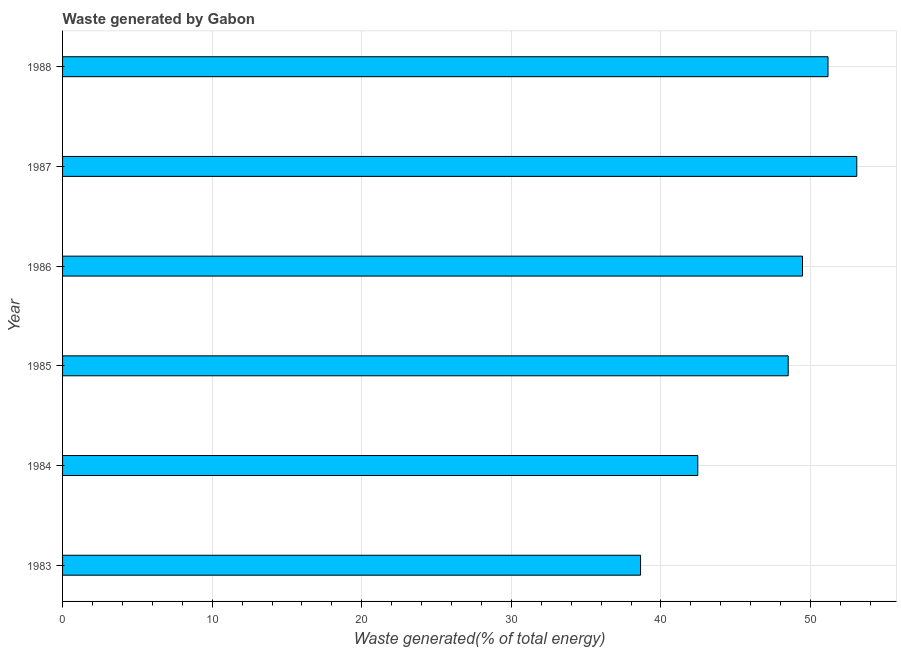Does the graph contain grids?
Your answer should be compact. Yes. What is the title of the graph?
Ensure brevity in your answer.  Waste generated by Gabon. What is the label or title of the X-axis?
Offer a terse response. Waste generated(% of total energy). What is the amount of waste generated in 1984?
Offer a terse response. 42.46. Across all years, what is the maximum amount of waste generated?
Give a very brief answer. 53.09. Across all years, what is the minimum amount of waste generated?
Make the answer very short. 38.64. In which year was the amount of waste generated maximum?
Your response must be concise. 1987. What is the sum of the amount of waste generated?
Provide a short and direct response. 283.33. What is the difference between the amount of waste generated in 1985 and 1986?
Make the answer very short. -0.95. What is the average amount of waste generated per year?
Provide a short and direct response. 47.22. What is the median amount of waste generated?
Keep it short and to the point. 48.99. In how many years, is the amount of waste generated greater than 34 %?
Your answer should be compact. 6. What is the ratio of the amount of waste generated in 1983 to that in 1986?
Ensure brevity in your answer.  0.78. Is the amount of waste generated in 1984 less than that in 1988?
Offer a terse response. Yes. What is the difference between the highest and the second highest amount of waste generated?
Your answer should be compact. 1.92. What is the difference between the highest and the lowest amount of waste generated?
Keep it short and to the point. 14.45. In how many years, is the amount of waste generated greater than the average amount of waste generated taken over all years?
Offer a terse response. 4. How many years are there in the graph?
Your answer should be very brief. 6. Are the values on the major ticks of X-axis written in scientific E-notation?
Keep it short and to the point. No. What is the Waste generated(% of total energy) in 1983?
Give a very brief answer. 38.64. What is the Waste generated(% of total energy) of 1984?
Your answer should be compact. 42.46. What is the Waste generated(% of total energy) in 1985?
Make the answer very short. 48.51. What is the Waste generated(% of total energy) of 1986?
Your answer should be compact. 49.46. What is the Waste generated(% of total energy) in 1987?
Your answer should be compact. 53.09. What is the Waste generated(% of total energy) in 1988?
Keep it short and to the point. 51.17. What is the difference between the Waste generated(% of total energy) in 1983 and 1984?
Offer a very short reply. -3.82. What is the difference between the Waste generated(% of total energy) in 1983 and 1985?
Make the answer very short. -9.87. What is the difference between the Waste generated(% of total energy) in 1983 and 1986?
Make the answer very short. -10.82. What is the difference between the Waste generated(% of total energy) in 1983 and 1987?
Provide a succinct answer. -14.45. What is the difference between the Waste generated(% of total energy) in 1983 and 1988?
Provide a succinct answer. -12.53. What is the difference between the Waste generated(% of total energy) in 1984 and 1985?
Your answer should be compact. -6.05. What is the difference between the Waste generated(% of total energy) in 1984 and 1986?
Make the answer very short. -7. What is the difference between the Waste generated(% of total energy) in 1984 and 1987?
Offer a very short reply. -10.63. What is the difference between the Waste generated(% of total energy) in 1984 and 1988?
Your answer should be compact. -8.71. What is the difference between the Waste generated(% of total energy) in 1985 and 1986?
Your answer should be compact. -0.95. What is the difference between the Waste generated(% of total energy) in 1985 and 1987?
Your response must be concise. -4.58. What is the difference between the Waste generated(% of total energy) in 1985 and 1988?
Your answer should be compact. -2.66. What is the difference between the Waste generated(% of total energy) in 1986 and 1987?
Your response must be concise. -3.63. What is the difference between the Waste generated(% of total energy) in 1986 and 1988?
Make the answer very short. -1.71. What is the difference between the Waste generated(% of total energy) in 1987 and 1988?
Make the answer very short. 1.92. What is the ratio of the Waste generated(% of total energy) in 1983 to that in 1984?
Your response must be concise. 0.91. What is the ratio of the Waste generated(% of total energy) in 1983 to that in 1985?
Offer a terse response. 0.8. What is the ratio of the Waste generated(% of total energy) in 1983 to that in 1986?
Offer a terse response. 0.78. What is the ratio of the Waste generated(% of total energy) in 1983 to that in 1987?
Your answer should be very brief. 0.73. What is the ratio of the Waste generated(% of total energy) in 1983 to that in 1988?
Provide a short and direct response. 0.76. What is the ratio of the Waste generated(% of total energy) in 1984 to that in 1985?
Make the answer very short. 0.88. What is the ratio of the Waste generated(% of total energy) in 1984 to that in 1986?
Provide a succinct answer. 0.86. What is the ratio of the Waste generated(% of total energy) in 1984 to that in 1988?
Provide a succinct answer. 0.83. What is the ratio of the Waste generated(% of total energy) in 1985 to that in 1986?
Offer a very short reply. 0.98. What is the ratio of the Waste generated(% of total energy) in 1985 to that in 1987?
Keep it short and to the point. 0.91. What is the ratio of the Waste generated(% of total energy) in 1985 to that in 1988?
Provide a succinct answer. 0.95. What is the ratio of the Waste generated(% of total energy) in 1986 to that in 1987?
Offer a very short reply. 0.93. What is the ratio of the Waste generated(% of total energy) in 1986 to that in 1988?
Ensure brevity in your answer.  0.97. What is the ratio of the Waste generated(% of total energy) in 1987 to that in 1988?
Give a very brief answer. 1.04. 